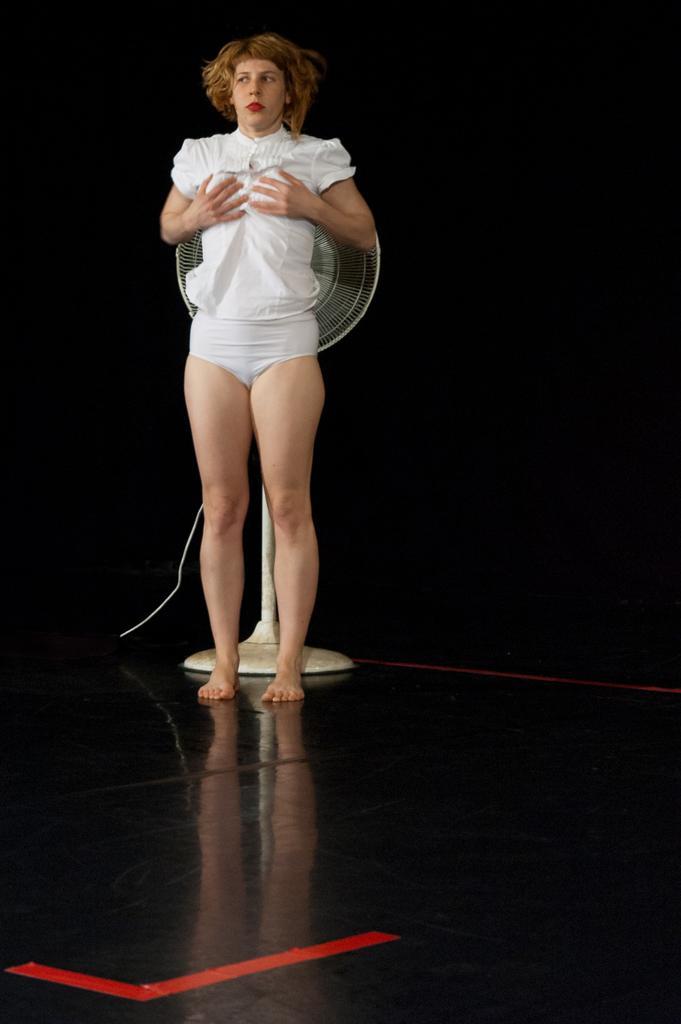How would you summarize this image in a sentence or two? In this picture we can see a woman standing and a table fan on the floor and in the background it is dark. 